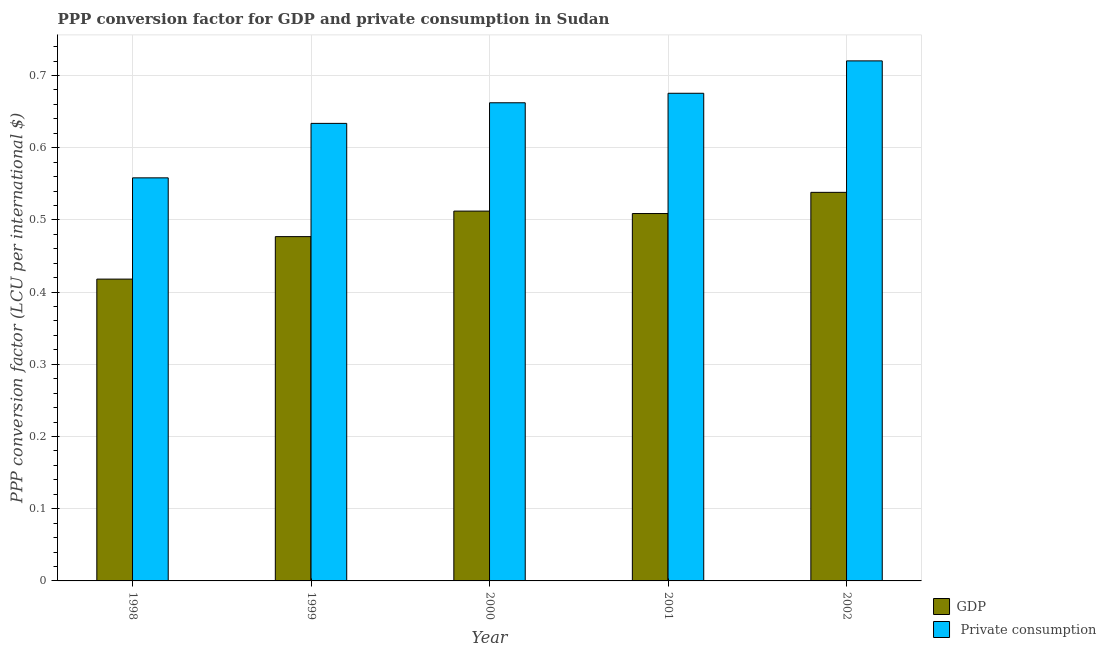How many different coloured bars are there?
Offer a terse response. 2. How many groups of bars are there?
Make the answer very short. 5. Are the number of bars on each tick of the X-axis equal?
Your response must be concise. Yes. How many bars are there on the 3rd tick from the right?
Provide a succinct answer. 2. What is the label of the 2nd group of bars from the left?
Give a very brief answer. 1999. What is the ppp conversion factor for gdp in 2000?
Your response must be concise. 0.51. Across all years, what is the maximum ppp conversion factor for gdp?
Your response must be concise. 0.54. Across all years, what is the minimum ppp conversion factor for gdp?
Your answer should be very brief. 0.42. In which year was the ppp conversion factor for gdp minimum?
Your answer should be compact. 1998. What is the total ppp conversion factor for gdp in the graph?
Offer a terse response. 2.45. What is the difference between the ppp conversion factor for gdp in 1998 and that in 1999?
Your answer should be compact. -0.06. What is the difference between the ppp conversion factor for private consumption in 2000 and the ppp conversion factor for gdp in 2001?
Your response must be concise. -0.01. What is the average ppp conversion factor for private consumption per year?
Your answer should be very brief. 0.65. In the year 2002, what is the difference between the ppp conversion factor for private consumption and ppp conversion factor for gdp?
Provide a succinct answer. 0. In how many years, is the ppp conversion factor for gdp greater than 0.6400000000000001 LCU?
Provide a short and direct response. 0. What is the ratio of the ppp conversion factor for gdp in 2000 to that in 2002?
Ensure brevity in your answer.  0.95. Is the ppp conversion factor for gdp in 1998 less than that in 1999?
Your answer should be compact. Yes. Is the difference between the ppp conversion factor for private consumption in 1999 and 2001 greater than the difference between the ppp conversion factor for gdp in 1999 and 2001?
Provide a succinct answer. No. What is the difference between the highest and the second highest ppp conversion factor for private consumption?
Keep it short and to the point. 0.04. What is the difference between the highest and the lowest ppp conversion factor for private consumption?
Offer a very short reply. 0.16. In how many years, is the ppp conversion factor for private consumption greater than the average ppp conversion factor for private consumption taken over all years?
Your answer should be compact. 3. Is the sum of the ppp conversion factor for private consumption in 2000 and 2002 greater than the maximum ppp conversion factor for gdp across all years?
Offer a terse response. Yes. What does the 1st bar from the left in 1999 represents?
Ensure brevity in your answer.  GDP. What does the 2nd bar from the right in 2000 represents?
Offer a very short reply. GDP. How many bars are there?
Give a very brief answer. 10. How many years are there in the graph?
Ensure brevity in your answer.  5. What is the difference between two consecutive major ticks on the Y-axis?
Give a very brief answer. 0.1. Are the values on the major ticks of Y-axis written in scientific E-notation?
Provide a succinct answer. No. Does the graph contain grids?
Provide a succinct answer. Yes. What is the title of the graph?
Provide a succinct answer. PPP conversion factor for GDP and private consumption in Sudan. What is the label or title of the X-axis?
Your answer should be very brief. Year. What is the label or title of the Y-axis?
Offer a terse response. PPP conversion factor (LCU per international $). What is the PPP conversion factor (LCU per international $) of GDP in 1998?
Provide a short and direct response. 0.42. What is the PPP conversion factor (LCU per international $) of  Private consumption in 1998?
Ensure brevity in your answer.  0.56. What is the PPP conversion factor (LCU per international $) in GDP in 1999?
Offer a very short reply. 0.48. What is the PPP conversion factor (LCU per international $) in  Private consumption in 1999?
Your response must be concise. 0.63. What is the PPP conversion factor (LCU per international $) of GDP in 2000?
Keep it short and to the point. 0.51. What is the PPP conversion factor (LCU per international $) of  Private consumption in 2000?
Keep it short and to the point. 0.66. What is the PPP conversion factor (LCU per international $) in GDP in 2001?
Ensure brevity in your answer.  0.51. What is the PPP conversion factor (LCU per international $) of  Private consumption in 2001?
Provide a short and direct response. 0.68. What is the PPP conversion factor (LCU per international $) in GDP in 2002?
Give a very brief answer. 0.54. What is the PPP conversion factor (LCU per international $) of  Private consumption in 2002?
Ensure brevity in your answer.  0.72. Across all years, what is the maximum PPP conversion factor (LCU per international $) in GDP?
Keep it short and to the point. 0.54. Across all years, what is the maximum PPP conversion factor (LCU per international $) of  Private consumption?
Keep it short and to the point. 0.72. Across all years, what is the minimum PPP conversion factor (LCU per international $) in GDP?
Your response must be concise. 0.42. Across all years, what is the minimum PPP conversion factor (LCU per international $) in  Private consumption?
Make the answer very short. 0.56. What is the total PPP conversion factor (LCU per international $) in GDP in the graph?
Offer a terse response. 2.45. What is the total PPP conversion factor (LCU per international $) of  Private consumption in the graph?
Make the answer very short. 3.25. What is the difference between the PPP conversion factor (LCU per international $) in GDP in 1998 and that in 1999?
Ensure brevity in your answer.  -0.06. What is the difference between the PPP conversion factor (LCU per international $) of  Private consumption in 1998 and that in 1999?
Your answer should be compact. -0.08. What is the difference between the PPP conversion factor (LCU per international $) of GDP in 1998 and that in 2000?
Make the answer very short. -0.09. What is the difference between the PPP conversion factor (LCU per international $) in  Private consumption in 1998 and that in 2000?
Offer a terse response. -0.1. What is the difference between the PPP conversion factor (LCU per international $) of GDP in 1998 and that in 2001?
Offer a terse response. -0.09. What is the difference between the PPP conversion factor (LCU per international $) of  Private consumption in 1998 and that in 2001?
Give a very brief answer. -0.12. What is the difference between the PPP conversion factor (LCU per international $) in GDP in 1998 and that in 2002?
Provide a succinct answer. -0.12. What is the difference between the PPP conversion factor (LCU per international $) in  Private consumption in 1998 and that in 2002?
Provide a short and direct response. -0.16. What is the difference between the PPP conversion factor (LCU per international $) in GDP in 1999 and that in 2000?
Provide a succinct answer. -0.04. What is the difference between the PPP conversion factor (LCU per international $) of  Private consumption in 1999 and that in 2000?
Ensure brevity in your answer.  -0.03. What is the difference between the PPP conversion factor (LCU per international $) in GDP in 1999 and that in 2001?
Provide a short and direct response. -0.03. What is the difference between the PPP conversion factor (LCU per international $) of  Private consumption in 1999 and that in 2001?
Your answer should be very brief. -0.04. What is the difference between the PPP conversion factor (LCU per international $) of GDP in 1999 and that in 2002?
Your response must be concise. -0.06. What is the difference between the PPP conversion factor (LCU per international $) of  Private consumption in 1999 and that in 2002?
Ensure brevity in your answer.  -0.09. What is the difference between the PPP conversion factor (LCU per international $) of GDP in 2000 and that in 2001?
Your response must be concise. 0. What is the difference between the PPP conversion factor (LCU per international $) of  Private consumption in 2000 and that in 2001?
Give a very brief answer. -0.01. What is the difference between the PPP conversion factor (LCU per international $) in GDP in 2000 and that in 2002?
Provide a short and direct response. -0.03. What is the difference between the PPP conversion factor (LCU per international $) in  Private consumption in 2000 and that in 2002?
Your answer should be very brief. -0.06. What is the difference between the PPP conversion factor (LCU per international $) in GDP in 2001 and that in 2002?
Give a very brief answer. -0.03. What is the difference between the PPP conversion factor (LCU per international $) in  Private consumption in 2001 and that in 2002?
Offer a terse response. -0.04. What is the difference between the PPP conversion factor (LCU per international $) in GDP in 1998 and the PPP conversion factor (LCU per international $) in  Private consumption in 1999?
Your response must be concise. -0.22. What is the difference between the PPP conversion factor (LCU per international $) in GDP in 1998 and the PPP conversion factor (LCU per international $) in  Private consumption in 2000?
Offer a very short reply. -0.24. What is the difference between the PPP conversion factor (LCU per international $) of GDP in 1998 and the PPP conversion factor (LCU per international $) of  Private consumption in 2001?
Give a very brief answer. -0.26. What is the difference between the PPP conversion factor (LCU per international $) in GDP in 1998 and the PPP conversion factor (LCU per international $) in  Private consumption in 2002?
Your answer should be very brief. -0.3. What is the difference between the PPP conversion factor (LCU per international $) of GDP in 1999 and the PPP conversion factor (LCU per international $) of  Private consumption in 2000?
Make the answer very short. -0.19. What is the difference between the PPP conversion factor (LCU per international $) in GDP in 1999 and the PPP conversion factor (LCU per international $) in  Private consumption in 2001?
Your answer should be compact. -0.2. What is the difference between the PPP conversion factor (LCU per international $) of GDP in 1999 and the PPP conversion factor (LCU per international $) of  Private consumption in 2002?
Provide a succinct answer. -0.24. What is the difference between the PPP conversion factor (LCU per international $) in GDP in 2000 and the PPP conversion factor (LCU per international $) in  Private consumption in 2001?
Ensure brevity in your answer.  -0.16. What is the difference between the PPP conversion factor (LCU per international $) of GDP in 2000 and the PPP conversion factor (LCU per international $) of  Private consumption in 2002?
Provide a short and direct response. -0.21. What is the difference between the PPP conversion factor (LCU per international $) in GDP in 2001 and the PPP conversion factor (LCU per international $) in  Private consumption in 2002?
Offer a terse response. -0.21. What is the average PPP conversion factor (LCU per international $) in GDP per year?
Offer a terse response. 0.49. What is the average PPP conversion factor (LCU per international $) in  Private consumption per year?
Your answer should be compact. 0.65. In the year 1998, what is the difference between the PPP conversion factor (LCU per international $) of GDP and PPP conversion factor (LCU per international $) of  Private consumption?
Keep it short and to the point. -0.14. In the year 1999, what is the difference between the PPP conversion factor (LCU per international $) of GDP and PPP conversion factor (LCU per international $) of  Private consumption?
Your response must be concise. -0.16. In the year 2000, what is the difference between the PPP conversion factor (LCU per international $) of GDP and PPP conversion factor (LCU per international $) of  Private consumption?
Provide a short and direct response. -0.15. In the year 2001, what is the difference between the PPP conversion factor (LCU per international $) of GDP and PPP conversion factor (LCU per international $) of  Private consumption?
Give a very brief answer. -0.17. In the year 2002, what is the difference between the PPP conversion factor (LCU per international $) of GDP and PPP conversion factor (LCU per international $) of  Private consumption?
Provide a short and direct response. -0.18. What is the ratio of the PPP conversion factor (LCU per international $) in GDP in 1998 to that in 1999?
Provide a succinct answer. 0.88. What is the ratio of the PPP conversion factor (LCU per international $) in  Private consumption in 1998 to that in 1999?
Your response must be concise. 0.88. What is the ratio of the PPP conversion factor (LCU per international $) in GDP in 1998 to that in 2000?
Your answer should be very brief. 0.82. What is the ratio of the PPP conversion factor (LCU per international $) in  Private consumption in 1998 to that in 2000?
Your answer should be compact. 0.84. What is the ratio of the PPP conversion factor (LCU per international $) in GDP in 1998 to that in 2001?
Give a very brief answer. 0.82. What is the ratio of the PPP conversion factor (LCU per international $) of  Private consumption in 1998 to that in 2001?
Provide a short and direct response. 0.83. What is the ratio of the PPP conversion factor (LCU per international $) in GDP in 1998 to that in 2002?
Your answer should be compact. 0.78. What is the ratio of the PPP conversion factor (LCU per international $) in  Private consumption in 1998 to that in 2002?
Give a very brief answer. 0.78. What is the ratio of the PPP conversion factor (LCU per international $) of GDP in 1999 to that in 2000?
Ensure brevity in your answer.  0.93. What is the ratio of the PPP conversion factor (LCU per international $) of  Private consumption in 1999 to that in 2000?
Provide a succinct answer. 0.96. What is the ratio of the PPP conversion factor (LCU per international $) of GDP in 1999 to that in 2001?
Give a very brief answer. 0.94. What is the ratio of the PPP conversion factor (LCU per international $) of  Private consumption in 1999 to that in 2001?
Offer a terse response. 0.94. What is the ratio of the PPP conversion factor (LCU per international $) of GDP in 1999 to that in 2002?
Give a very brief answer. 0.89. What is the ratio of the PPP conversion factor (LCU per international $) in  Private consumption in 1999 to that in 2002?
Give a very brief answer. 0.88. What is the ratio of the PPP conversion factor (LCU per international $) of GDP in 2000 to that in 2001?
Your response must be concise. 1.01. What is the ratio of the PPP conversion factor (LCU per international $) in  Private consumption in 2000 to that in 2001?
Provide a succinct answer. 0.98. What is the ratio of the PPP conversion factor (LCU per international $) of GDP in 2000 to that in 2002?
Provide a succinct answer. 0.95. What is the ratio of the PPP conversion factor (LCU per international $) in  Private consumption in 2000 to that in 2002?
Provide a succinct answer. 0.92. What is the ratio of the PPP conversion factor (LCU per international $) of GDP in 2001 to that in 2002?
Offer a terse response. 0.95. What is the ratio of the PPP conversion factor (LCU per international $) in  Private consumption in 2001 to that in 2002?
Your answer should be compact. 0.94. What is the difference between the highest and the second highest PPP conversion factor (LCU per international $) in GDP?
Your answer should be compact. 0.03. What is the difference between the highest and the second highest PPP conversion factor (LCU per international $) of  Private consumption?
Provide a succinct answer. 0.04. What is the difference between the highest and the lowest PPP conversion factor (LCU per international $) in GDP?
Provide a succinct answer. 0.12. What is the difference between the highest and the lowest PPP conversion factor (LCU per international $) of  Private consumption?
Offer a terse response. 0.16. 